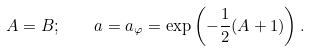<formula> <loc_0><loc_0><loc_500><loc_500>A = B ; \quad a = a _ { \varphi } = \exp \left ( - \frac { 1 } { 2 } ( A + 1 ) \right ) .</formula> 